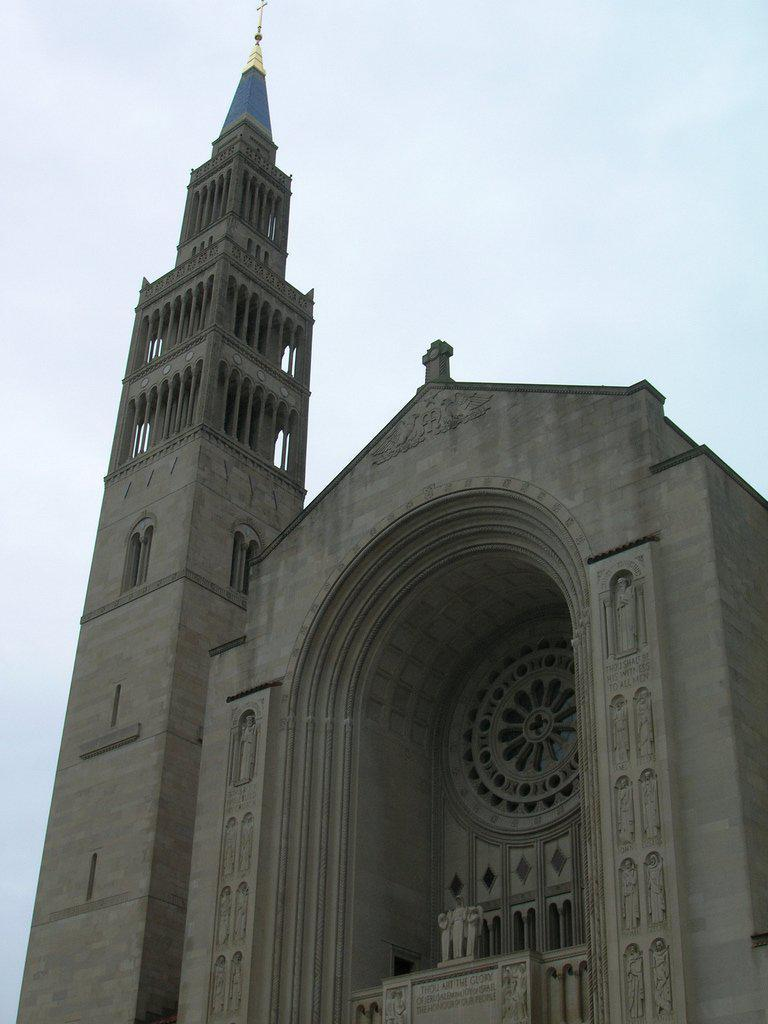What structure is located on the left side of the image? There is a tower on the left side of the image. What other structure is near the tower? There is a building beside the tower. What can be seen in the sky in the background of the image? There are clouds in the sky in the background of the image. How many ants can be seen climbing the tower in the image? There are no ants present in the image; it features a tower and a building. What is the income of the people living in the building beside the tower? The income of the people living in the building cannot be determined from the image. 